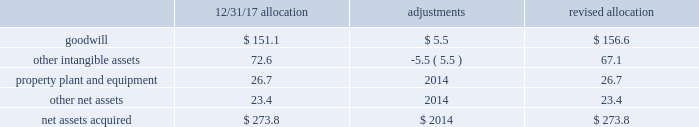Sacramento container acquisition in october 2017 , pca acquired substantially all of the assets of sacramento container corporation , and 100% ( 100 % ) of the membership interests of northern sheets , llc and central california sheets , llc ( collectively referred to as 201csacramento container 201d ) for a purchase price of $ 274 million , including working capital adjustments .
Funding for the acquisition came from available cash on hand .
Assets acquired include full-line corrugated products and sheet feeder operations in both mcclellan , california and kingsburg , california .
Sacramento container provides packaging solutions to customers serving portions of california 2019s strong agricultural market .
Sacramento container 2019s financial results are included in the packaging segment from the date of acquisition .
The company accounted for the sacramento container acquisition using the acquisition method of accounting in accordance with asc 805 , business combinations .
The total purchase price has been allocated to tangible and intangible assets acquired and liabilities assumed based on respective fair values , as follows ( dollars in millions ) : .
During the second quarter ended june 30 , 2018 , we made a $ 5.5 million net adjustment based on the final valuation of the intangible assets .
We recorded the adjustment as a decrease to other intangible assets with an offset to goodwill .
Goodwill is calculated as the excess of the purchase price over the fair value of the net assets acquired .
Among the factors that contributed to the recognition of goodwill were sacramento container 2019s commitment to continuous improvement and regional synergies , as well as the expected increases in pca 2019s containerboard integration levels .
Goodwill is deductible for tax purposes .
Other intangible assets , primarily customer relationships , were assigned an estimated weighted average useful life of 9.6 years .
Property , plant and equipment were assigned estimated useful lives ranging from one to 13 years. .
For the revised total purchase price allocation , property plant and equipment was what percentage of net assets acquired? 
Computations: (26.7 / 273.8)
Answer: 0.09752. 